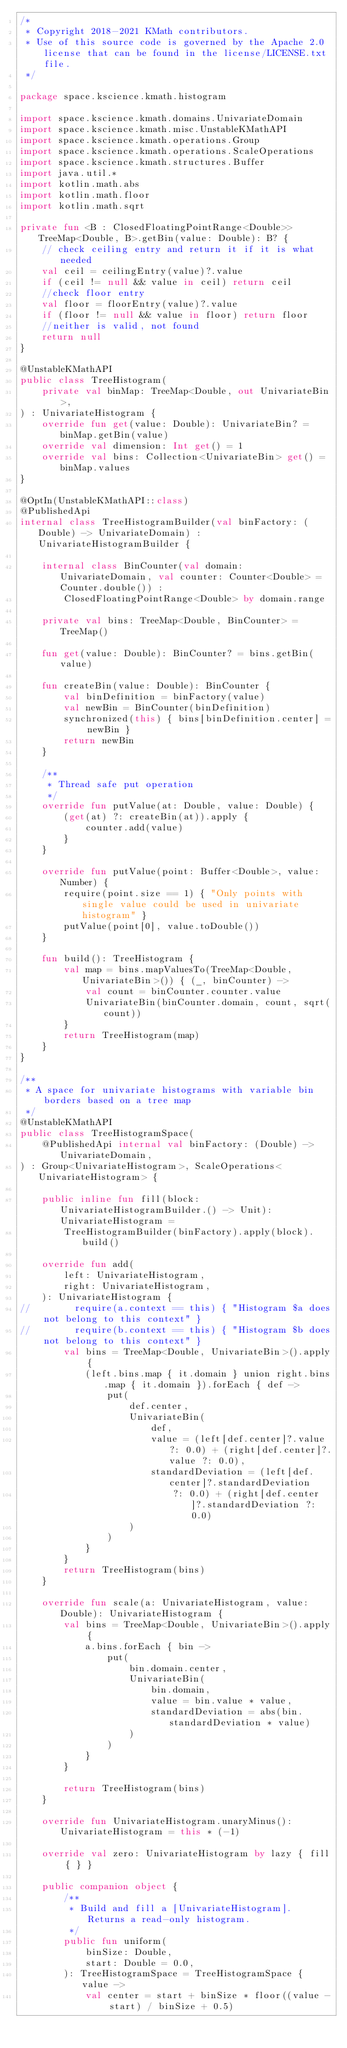Convert code to text. <code><loc_0><loc_0><loc_500><loc_500><_Kotlin_>/*
 * Copyright 2018-2021 KMath contributors.
 * Use of this source code is governed by the Apache 2.0 license that can be found in the license/LICENSE.txt file.
 */

package space.kscience.kmath.histogram

import space.kscience.kmath.domains.UnivariateDomain
import space.kscience.kmath.misc.UnstableKMathAPI
import space.kscience.kmath.operations.Group
import space.kscience.kmath.operations.ScaleOperations
import space.kscience.kmath.structures.Buffer
import java.util.*
import kotlin.math.abs
import kotlin.math.floor
import kotlin.math.sqrt

private fun <B : ClosedFloatingPointRange<Double>> TreeMap<Double, B>.getBin(value: Double): B? {
    // check ceiling entry and return it if it is what needed
    val ceil = ceilingEntry(value)?.value
    if (ceil != null && value in ceil) return ceil
    //check floor entry
    val floor = floorEntry(value)?.value
    if (floor != null && value in floor) return floor
    //neither is valid, not found
    return null
}

@UnstableKMathAPI
public class TreeHistogram(
    private val binMap: TreeMap<Double, out UnivariateBin>,
) : UnivariateHistogram {
    override fun get(value: Double): UnivariateBin? = binMap.getBin(value)
    override val dimension: Int get() = 1
    override val bins: Collection<UnivariateBin> get() = binMap.values
}

@OptIn(UnstableKMathAPI::class)
@PublishedApi
internal class TreeHistogramBuilder(val binFactory: (Double) -> UnivariateDomain) : UnivariateHistogramBuilder {

    internal class BinCounter(val domain: UnivariateDomain, val counter: Counter<Double> = Counter.double()) :
        ClosedFloatingPointRange<Double> by domain.range

    private val bins: TreeMap<Double, BinCounter> = TreeMap()

    fun get(value: Double): BinCounter? = bins.getBin(value)

    fun createBin(value: Double): BinCounter {
        val binDefinition = binFactory(value)
        val newBin = BinCounter(binDefinition)
        synchronized(this) { bins[binDefinition.center] = newBin }
        return newBin
    }

    /**
     * Thread safe put operation
     */
    override fun putValue(at: Double, value: Double) {
        (get(at) ?: createBin(at)).apply {
            counter.add(value)
        }
    }

    override fun putValue(point: Buffer<Double>, value: Number) {
        require(point.size == 1) { "Only points with single value could be used in univariate histogram" }
        putValue(point[0], value.toDouble())
    }

    fun build(): TreeHistogram {
        val map = bins.mapValuesTo(TreeMap<Double, UnivariateBin>()) { (_, binCounter) ->
            val count = binCounter.counter.value
            UnivariateBin(binCounter.domain, count, sqrt(count))
        }
        return TreeHistogram(map)
    }
}

/**
 * A space for univariate histograms with variable bin borders based on a tree map
 */
@UnstableKMathAPI
public class TreeHistogramSpace(
    @PublishedApi internal val binFactory: (Double) -> UnivariateDomain,
) : Group<UnivariateHistogram>, ScaleOperations<UnivariateHistogram> {

    public inline fun fill(block: UnivariateHistogramBuilder.() -> Unit): UnivariateHistogram =
        TreeHistogramBuilder(binFactory).apply(block).build()

    override fun add(
        left: UnivariateHistogram,
        right: UnivariateHistogram,
    ): UnivariateHistogram {
//        require(a.context == this) { "Histogram $a does not belong to this context" }
//        require(b.context == this) { "Histogram $b does not belong to this context" }
        val bins = TreeMap<Double, UnivariateBin>().apply {
            (left.bins.map { it.domain } union right.bins.map { it.domain }).forEach { def ->
                put(
                    def.center,
                    UnivariateBin(
                        def,
                        value = (left[def.center]?.value ?: 0.0) + (right[def.center]?.value ?: 0.0),
                        standardDeviation = (left[def.center]?.standardDeviation
                            ?: 0.0) + (right[def.center]?.standardDeviation ?: 0.0)
                    )
                )
            }
        }
        return TreeHistogram(bins)
    }

    override fun scale(a: UnivariateHistogram, value: Double): UnivariateHistogram {
        val bins = TreeMap<Double, UnivariateBin>().apply {
            a.bins.forEach { bin ->
                put(
                    bin.domain.center,
                    UnivariateBin(
                        bin.domain,
                        value = bin.value * value,
                        standardDeviation = abs(bin.standardDeviation * value)
                    )
                )
            }
        }

        return TreeHistogram(bins)
    }

    override fun UnivariateHistogram.unaryMinus(): UnivariateHistogram = this * (-1)

    override val zero: UnivariateHistogram by lazy { fill { } }

    public companion object {
        /**
         * Build and fill a [UnivariateHistogram]. Returns a read-only histogram.
         */
        public fun uniform(
            binSize: Double,
            start: Double = 0.0,
        ): TreeHistogramSpace = TreeHistogramSpace { value ->
            val center = start + binSize * floor((value - start) / binSize + 0.5)</code> 